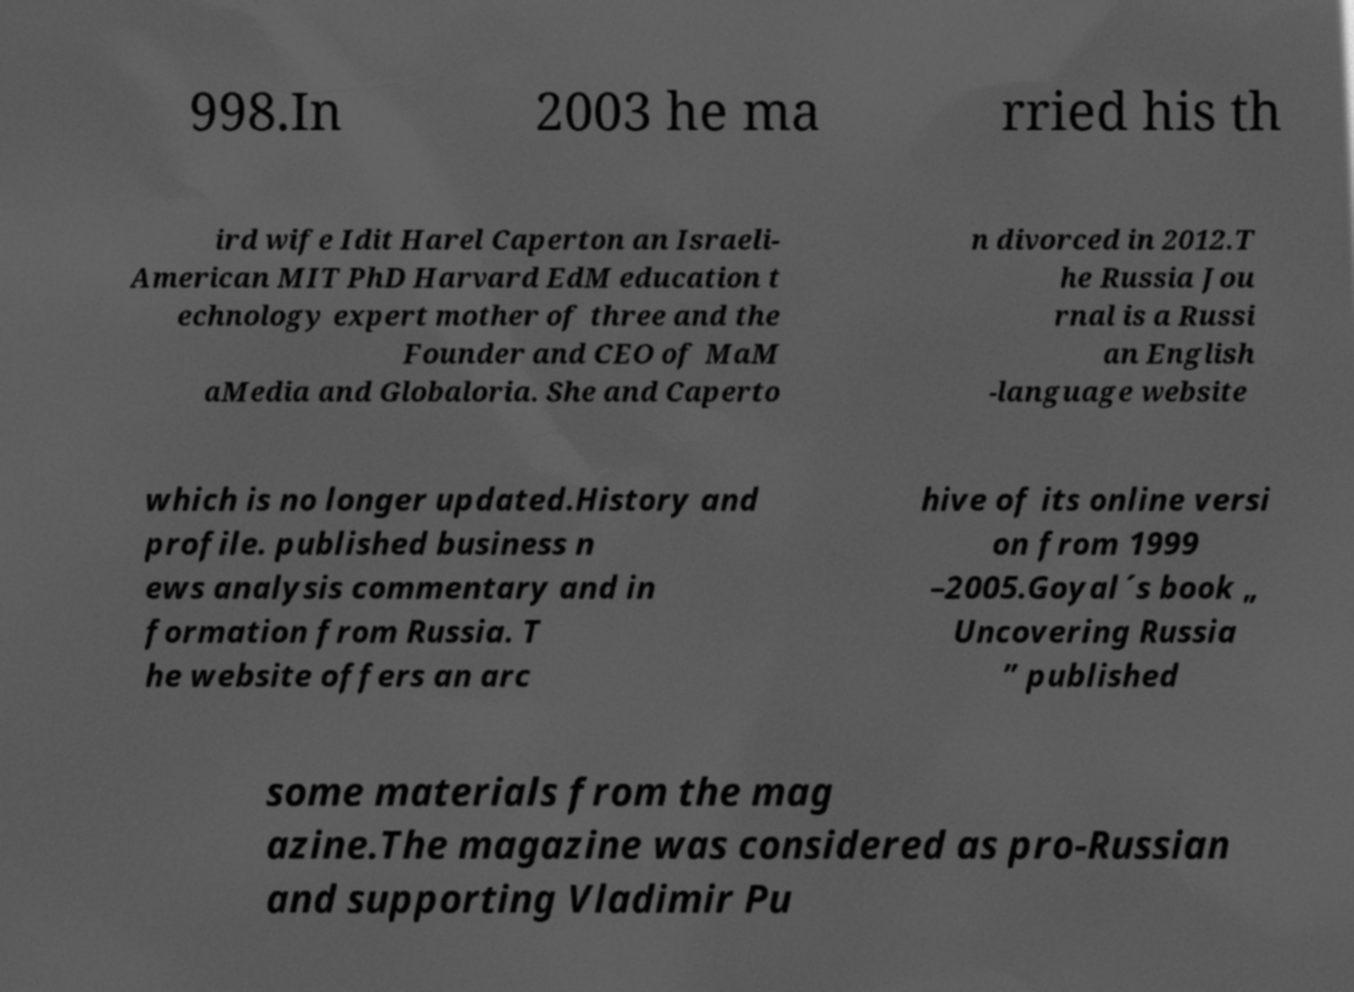Please read and relay the text visible in this image. What does it say? 998.In 2003 he ma rried his th ird wife Idit Harel Caperton an Israeli- American MIT PhD Harvard EdM education t echnology expert mother of three and the Founder and CEO of MaM aMedia and Globaloria. She and Caperto n divorced in 2012.T he Russia Jou rnal is a Russi an English -language website which is no longer updated.History and profile. published business n ews analysis commentary and in formation from Russia. T he website offers an arc hive of its online versi on from 1999 –2005.Goyal´s book „ Uncovering Russia ” published some materials from the mag azine.The magazine was considered as pro-Russian and supporting Vladimir Pu 